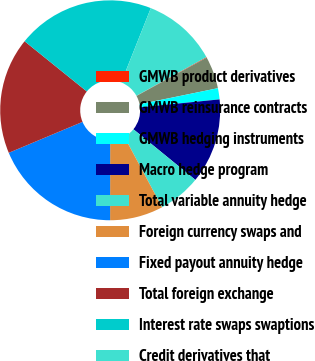Convert chart. <chart><loc_0><loc_0><loc_500><loc_500><pie_chart><fcel>GMWB product derivatives<fcel>GMWB reinsurance contracts<fcel>GMWB hedging instruments<fcel>Macro hedge program<fcel>Total variable annuity hedge<fcel>Foreign currency swaps and<fcel>Fixed payout annuity hedge<fcel>Total foreign exchange<fcel>Interest rate swaps swaptions<fcel>Credit derivatives that<nl><fcel>0.09%<fcel>4.73%<fcel>1.64%<fcel>12.48%<fcel>6.28%<fcel>7.83%<fcel>18.67%<fcel>17.12%<fcel>20.22%<fcel>10.93%<nl></chart> 